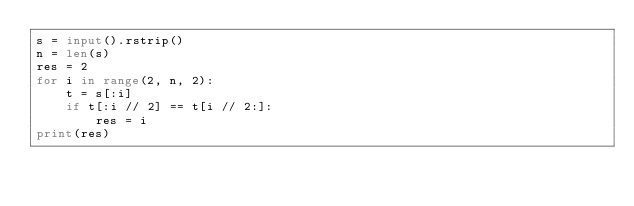<code> <loc_0><loc_0><loc_500><loc_500><_Python_>s = input().rstrip()
n = len(s)
res = 2
for i in range(2, n, 2):
    t = s[:i]
    if t[:i // 2] == t[i // 2:]:
        res = i
print(res)</code> 